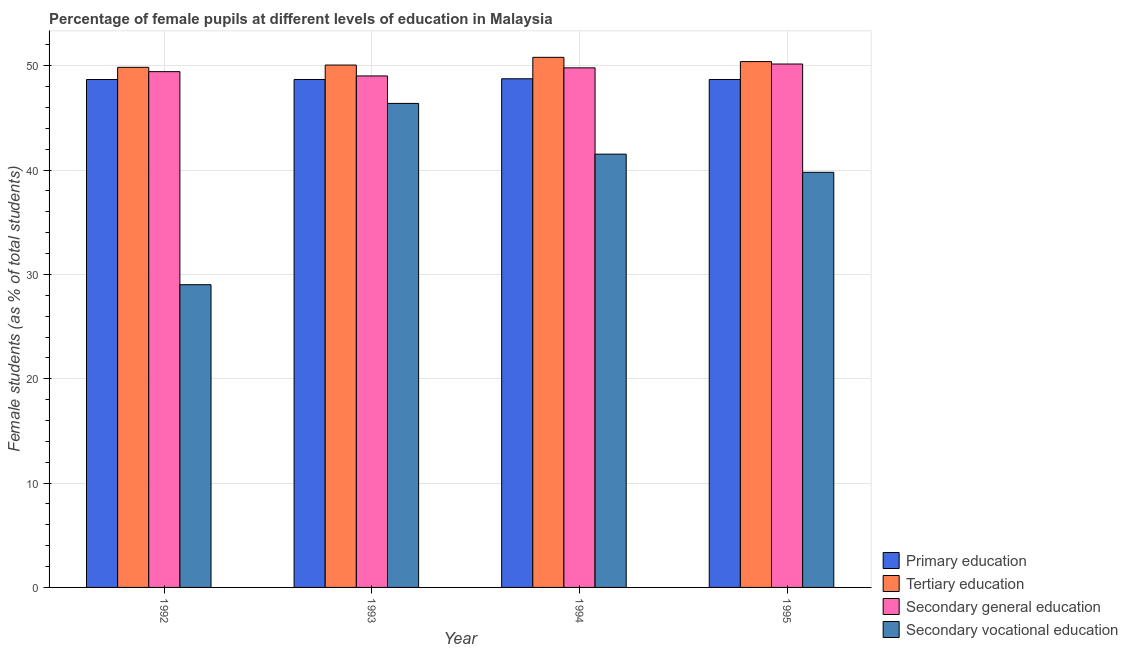How many bars are there on the 4th tick from the left?
Make the answer very short. 4. How many bars are there on the 1st tick from the right?
Make the answer very short. 4. What is the label of the 3rd group of bars from the left?
Provide a short and direct response. 1994. In how many cases, is the number of bars for a given year not equal to the number of legend labels?
Provide a short and direct response. 0. What is the percentage of female students in tertiary education in 1993?
Your answer should be very brief. 50.07. Across all years, what is the maximum percentage of female students in secondary vocational education?
Offer a very short reply. 46.39. Across all years, what is the minimum percentage of female students in secondary education?
Your answer should be very brief. 49.03. What is the total percentage of female students in tertiary education in the graph?
Offer a very short reply. 201.14. What is the difference between the percentage of female students in tertiary education in 1993 and that in 1995?
Provide a succinct answer. -0.33. What is the difference between the percentage of female students in secondary vocational education in 1992 and the percentage of female students in primary education in 1994?
Your answer should be very brief. -12.52. What is the average percentage of female students in primary education per year?
Give a very brief answer. 48.7. In how many years, is the percentage of female students in secondary vocational education greater than 48 %?
Your answer should be compact. 0. What is the ratio of the percentage of female students in secondary vocational education in 1994 to that in 1995?
Give a very brief answer. 1.04. Is the percentage of female students in secondary vocational education in 1993 less than that in 1994?
Your response must be concise. No. Is the difference between the percentage of female students in tertiary education in 1992 and 1994 greater than the difference between the percentage of female students in primary education in 1992 and 1994?
Provide a succinct answer. No. What is the difference between the highest and the second highest percentage of female students in secondary education?
Offer a terse response. 0.37. What is the difference between the highest and the lowest percentage of female students in secondary education?
Keep it short and to the point. 1.14. Is the sum of the percentage of female students in tertiary education in 1992 and 1995 greater than the maximum percentage of female students in primary education across all years?
Provide a short and direct response. Yes. Is it the case that in every year, the sum of the percentage of female students in primary education and percentage of female students in secondary education is greater than the sum of percentage of female students in secondary vocational education and percentage of female students in tertiary education?
Make the answer very short. No. What does the 3rd bar from the left in 1992 represents?
Your response must be concise. Secondary general education. What does the 3rd bar from the right in 1995 represents?
Your answer should be very brief. Tertiary education. How many bars are there?
Keep it short and to the point. 16. Are all the bars in the graph horizontal?
Your answer should be compact. No. What is the difference between two consecutive major ticks on the Y-axis?
Offer a very short reply. 10. Does the graph contain any zero values?
Make the answer very short. No. How are the legend labels stacked?
Make the answer very short. Vertical. What is the title of the graph?
Your answer should be very brief. Percentage of female pupils at different levels of education in Malaysia. Does "Social Protection" appear as one of the legend labels in the graph?
Give a very brief answer. No. What is the label or title of the X-axis?
Your answer should be very brief. Year. What is the label or title of the Y-axis?
Your response must be concise. Female students (as % of total students). What is the Female students (as % of total students) of Primary education in 1992?
Provide a succinct answer. 48.69. What is the Female students (as % of total students) in Tertiary education in 1992?
Provide a short and direct response. 49.85. What is the Female students (as % of total students) of Secondary general education in 1992?
Your answer should be very brief. 49.44. What is the Female students (as % of total students) of Secondary vocational education in 1992?
Keep it short and to the point. 29.02. What is the Female students (as % of total students) of Primary education in 1993?
Offer a terse response. 48.69. What is the Female students (as % of total students) in Tertiary education in 1993?
Your response must be concise. 50.07. What is the Female students (as % of total students) in Secondary general education in 1993?
Give a very brief answer. 49.03. What is the Female students (as % of total students) of Secondary vocational education in 1993?
Make the answer very short. 46.39. What is the Female students (as % of total students) of Primary education in 1994?
Your response must be concise. 48.76. What is the Female students (as % of total students) in Tertiary education in 1994?
Offer a very short reply. 50.81. What is the Female students (as % of total students) in Secondary general education in 1994?
Provide a short and direct response. 49.8. What is the Female students (as % of total students) in Secondary vocational education in 1994?
Keep it short and to the point. 41.53. What is the Female students (as % of total students) in Primary education in 1995?
Your response must be concise. 48.69. What is the Female students (as % of total students) in Tertiary education in 1995?
Offer a terse response. 50.4. What is the Female students (as % of total students) of Secondary general education in 1995?
Give a very brief answer. 50.17. What is the Female students (as % of total students) of Secondary vocational education in 1995?
Keep it short and to the point. 39.79. Across all years, what is the maximum Female students (as % of total students) in Primary education?
Your answer should be compact. 48.76. Across all years, what is the maximum Female students (as % of total students) of Tertiary education?
Provide a succinct answer. 50.81. Across all years, what is the maximum Female students (as % of total students) in Secondary general education?
Provide a short and direct response. 50.17. Across all years, what is the maximum Female students (as % of total students) in Secondary vocational education?
Offer a very short reply. 46.39. Across all years, what is the minimum Female students (as % of total students) of Primary education?
Your answer should be very brief. 48.69. Across all years, what is the minimum Female students (as % of total students) in Tertiary education?
Ensure brevity in your answer.  49.85. Across all years, what is the minimum Female students (as % of total students) of Secondary general education?
Provide a succinct answer. 49.03. Across all years, what is the minimum Female students (as % of total students) of Secondary vocational education?
Your answer should be compact. 29.02. What is the total Female students (as % of total students) of Primary education in the graph?
Give a very brief answer. 194.82. What is the total Female students (as % of total students) of Tertiary education in the graph?
Keep it short and to the point. 201.14. What is the total Female students (as % of total students) of Secondary general education in the graph?
Offer a terse response. 198.44. What is the total Female students (as % of total students) of Secondary vocational education in the graph?
Make the answer very short. 156.73. What is the difference between the Female students (as % of total students) of Primary education in 1992 and that in 1993?
Ensure brevity in your answer.  -0. What is the difference between the Female students (as % of total students) of Tertiary education in 1992 and that in 1993?
Your answer should be compact. -0.22. What is the difference between the Female students (as % of total students) in Secondary general education in 1992 and that in 1993?
Your response must be concise. 0.41. What is the difference between the Female students (as % of total students) in Secondary vocational education in 1992 and that in 1993?
Your response must be concise. -17.38. What is the difference between the Female students (as % of total students) of Primary education in 1992 and that in 1994?
Your answer should be very brief. -0.07. What is the difference between the Female students (as % of total students) in Tertiary education in 1992 and that in 1994?
Give a very brief answer. -0.96. What is the difference between the Female students (as % of total students) of Secondary general education in 1992 and that in 1994?
Offer a very short reply. -0.36. What is the difference between the Female students (as % of total students) of Secondary vocational education in 1992 and that in 1994?
Your response must be concise. -12.52. What is the difference between the Female students (as % of total students) in Primary education in 1992 and that in 1995?
Offer a very short reply. -0. What is the difference between the Female students (as % of total students) of Tertiary education in 1992 and that in 1995?
Provide a short and direct response. -0.55. What is the difference between the Female students (as % of total students) in Secondary general education in 1992 and that in 1995?
Your response must be concise. -0.73. What is the difference between the Female students (as % of total students) in Secondary vocational education in 1992 and that in 1995?
Give a very brief answer. -10.77. What is the difference between the Female students (as % of total students) of Primary education in 1993 and that in 1994?
Give a very brief answer. -0.07. What is the difference between the Female students (as % of total students) of Tertiary education in 1993 and that in 1994?
Make the answer very short. -0.74. What is the difference between the Female students (as % of total students) of Secondary general education in 1993 and that in 1994?
Provide a succinct answer. -0.78. What is the difference between the Female students (as % of total students) in Secondary vocational education in 1993 and that in 1994?
Make the answer very short. 4.86. What is the difference between the Female students (as % of total students) in Primary education in 1993 and that in 1995?
Ensure brevity in your answer.  -0. What is the difference between the Female students (as % of total students) of Tertiary education in 1993 and that in 1995?
Ensure brevity in your answer.  -0.33. What is the difference between the Female students (as % of total students) in Secondary general education in 1993 and that in 1995?
Your answer should be very brief. -1.14. What is the difference between the Female students (as % of total students) of Secondary vocational education in 1993 and that in 1995?
Provide a succinct answer. 6.61. What is the difference between the Female students (as % of total students) in Primary education in 1994 and that in 1995?
Provide a short and direct response. 0.07. What is the difference between the Female students (as % of total students) in Tertiary education in 1994 and that in 1995?
Give a very brief answer. 0.41. What is the difference between the Female students (as % of total students) of Secondary general education in 1994 and that in 1995?
Your answer should be very brief. -0.37. What is the difference between the Female students (as % of total students) of Secondary vocational education in 1994 and that in 1995?
Your answer should be very brief. 1.74. What is the difference between the Female students (as % of total students) in Primary education in 1992 and the Female students (as % of total students) in Tertiary education in 1993?
Make the answer very short. -1.38. What is the difference between the Female students (as % of total students) of Primary education in 1992 and the Female students (as % of total students) of Secondary general education in 1993?
Provide a short and direct response. -0.34. What is the difference between the Female students (as % of total students) of Primary education in 1992 and the Female students (as % of total students) of Secondary vocational education in 1993?
Provide a succinct answer. 2.29. What is the difference between the Female students (as % of total students) in Tertiary education in 1992 and the Female students (as % of total students) in Secondary general education in 1993?
Offer a terse response. 0.83. What is the difference between the Female students (as % of total students) of Tertiary education in 1992 and the Female students (as % of total students) of Secondary vocational education in 1993?
Provide a short and direct response. 3.46. What is the difference between the Female students (as % of total students) in Secondary general education in 1992 and the Female students (as % of total students) in Secondary vocational education in 1993?
Ensure brevity in your answer.  3.04. What is the difference between the Female students (as % of total students) of Primary education in 1992 and the Female students (as % of total students) of Tertiary education in 1994?
Give a very brief answer. -2.13. What is the difference between the Female students (as % of total students) in Primary education in 1992 and the Female students (as % of total students) in Secondary general education in 1994?
Offer a very short reply. -1.12. What is the difference between the Female students (as % of total students) of Primary education in 1992 and the Female students (as % of total students) of Secondary vocational education in 1994?
Give a very brief answer. 7.16. What is the difference between the Female students (as % of total students) of Tertiary education in 1992 and the Female students (as % of total students) of Secondary general education in 1994?
Offer a terse response. 0.05. What is the difference between the Female students (as % of total students) of Tertiary education in 1992 and the Female students (as % of total students) of Secondary vocational education in 1994?
Offer a terse response. 8.32. What is the difference between the Female students (as % of total students) of Secondary general education in 1992 and the Female students (as % of total students) of Secondary vocational education in 1994?
Offer a terse response. 7.91. What is the difference between the Female students (as % of total students) of Primary education in 1992 and the Female students (as % of total students) of Tertiary education in 1995?
Offer a terse response. -1.72. What is the difference between the Female students (as % of total students) in Primary education in 1992 and the Female students (as % of total students) in Secondary general education in 1995?
Make the answer very short. -1.48. What is the difference between the Female students (as % of total students) in Primary education in 1992 and the Female students (as % of total students) in Secondary vocational education in 1995?
Make the answer very short. 8.9. What is the difference between the Female students (as % of total students) in Tertiary education in 1992 and the Female students (as % of total students) in Secondary general education in 1995?
Your answer should be compact. -0.32. What is the difference between the Female students (as % of total students) in Tertiary education in 1992 and the Female students (as % of total students) in Secondary vocational education in 1995?
Ensure brevity in your answer.  10.06. What is the difference between the Female students (as % of total students) in Secondary general education in 1992 and the Female students (as % of total students) in Secondary vocational education in 1995?
Ensure brevity in your answer.  9.65. What is the difference between the Female students (as % of total students) of Primary education in 1993 and the Female students (as % of total students) of Tertiary education in 1994?
Keep it short and to the point. -2.12. What is the difference between the Female students (as % of total students) of Primary education in 1993 and the Female students (as % of total students) of Secondary general education in 1994?
Ensure brevity in your answer.  -1.11. What is the difference between the Female students (as % of total students) of Primary education in 1993 and the Female students (as % of total students) of Secondary vocational education in 1994?
Your answer should be compact. 7.16. What is the difference between the Female students (as % of total students) in Tertiary education in 1993 and the Female students (as % of total students) in Secondary general education in 1994?
Make the answer very short. 0.27. What is the difference between the Female students (as % of total students) of Tertiary education in 1993 and the Female students (as % of total students) of Secondary vocational education in 1994?
Provide a short and direct response. 8.54. What is the difference between the Female students (as % of total students) in Secondary general education in 1993 and the Female students (as % of total students) in Secondary vocational education in 1994?
Offer a terse response. 7.5. What is the difference between the Female students (as % of total students) in Primary education in 1993 and the Female students (as % of total students) in Tertiary education in 1995?
Give a very brief answer. -1.71. What is the difference between the Female students (as % of total students) in Primary education in 1993 and the Female students (as % of total students) in Secondary general education in 1995?
Offer a terse response. -1.48. What is the difference between the Female students (as % of total students) of Primary education in 1993 and the Female students (as % of total students) of Secondary vocational education in 1995?
Your answer should be very brief. 8.9. What is the difference between the Female students (as % of total students) in Tertiary education in 1993 and the Female students (as % of total students) in Secondary general education in 1995?
Your answer should be compact. -0.1. What is the difference between the Female students (as % of total students) of Tertiary education in 1993 and the Female students (as % of total students) of Secondary vocational education in 1995?
Provide a succinct answer. 10.28. What is the difference between the Female students (as % of total students) of Secondary general education in 1993 and the Female students (as % of total students) of Secondary vocational education in 1995?
Your response must be concise. 9.24. What is the difference between the Female students (as % of total students) in Primary education in 1994 and the Female students (as % of total students) in Tertiary education in 1995?
Provide a short and direct response. -1.65. What is the difference between the Female students (as % of total students) in Primary education in 1994 and the Female students (as % of total students) in Secondary general education in 1995?
Make the answer very short. -1.41. What is the difference between the Female students (as % of total students) in Primary education in 1994 and the Female students (as % of total students) in Secondary vocational education in 1995?
Make the answer very short. 8.97. What is the difference between the Female students (as % of total students) in Tertiary education in 1994 and the Female students (as % of total students) in Secondary general education in 1995?
Ensure brevity in your answer.  0.64. What is the difference between the Female students (as % of total students) of Tertiary education in 1994 and the Female students (as % of total students) of Secondary vocational education in 1995?
Provide a succinct answer. 11.02. What is the difference between the Female students (as % of total students) of Secondary general education in 1994 and the Female students (as % of total students) of Secondary vocational education in 1995?
Your response must be concise. 10.01. What is the average Female students (as % of total students) of Primary education per year?
Offer a very short reply. 48.7. What is the average Female students (as % of total students) in Tertiary education per year?
Provide a succinct answer. 50.28. What is the average Female students (as % of total students) in Secondary general education per year?
Offer a terse response. 49.61. What is the average Female students (as % of total students) of Secondary vocational education per year?
Give a very brief answer. 39.18. In the year 1992, what is the difference between the Female students (as % of total students) in Primary education and Female students (as % of total students) in Tertiary education?
Offer a terse response. -1.17. In the year 1992, what is the difference between the Female students (as % of total students) in Primary education and Female students (as % of total students) in Secondary general education?
Provide a succinct answer. -0.75. In the year 1992, what is the difference between the Female students (as % of total students) in Primary education and Female students (as % of total students) in Secondary vocational education?
Keep it short and to the point. 19.67. In the year 1992, what is the difference between the Female students (as % of total students) in Tertiary education and Female students (as % of total students) in Secondary general education?
Your answer should be compact. 0.41. In the year 1992, what is the difference between the Female students (as % of total students) of Tertiary education and Female students (as % of total students) of Secondary vocational education?
Your answer should be very brief. 20.84. In the year 1992, what is the difference between the Female students (as % of total students) of Secondary general education and Female students (as % of total students) of Secondary vocational education?
Offer a very short reply. 20.42. In the year 1993, what is the difference between the Female students (as % of total students) in Primary education and Female students (as % of total students) in Tertiary education?
Your answer should be very brief. -1.38. In the year 1993, what is the difference between the Female students (as % of total students) of Primary education and Female students (as % of total students) of Secondary general education?
Give a very brief answer. -0.34. In the year 1993, what is the difference between the Female students (as % of total students) of Primary education and Female students (as % of total students) of Secondary vocational education?
Give a very brief answer. 2.29. In the year 1993, what is the difference between the Female students (as % of total students) in Tertiary education and Female students (as % of total students) in Secondary general education?
Keep it short and to the point. 1.04. In the year 1993, what is the difference between the Female students (as % of total students) of Tertiary education and Female students (as % of total students) of Secondary vocational education?
Your response must be concise. 3.68. In the year 1993, what is the difference between the Female students (as % of total students) of Secondary general education and Female students (as % of total students) of Secondary vocational education?
Your answer should be compact. 2.63. In the year 1994, what is the difference between the Female students (as % of total students) of Primary education and Female students (as % of total students) of Tertiary education?
Offer a terse response. -2.05. In the year 1994, what is the difference between the Female students (as % of total students) in Primary education and Female students (as % of total students) in Secondary general education?
Your response must be concise. -1.05. In the year 1994, what is the difference between the Female students (as % of total students) in Primary education and Female students (as % of total students) in Secondary vocational education?
Provide a succinct answer. 7.23. In the year 1994, what is the difference between the Female students (as % of total students) of Tertiary education and Female students (as % of total students) of Secondary general education?
Your response must be concise. 1.01. In the year 1994, what is the difference between the Female students (as % of total students) of Tertiary education and Female students (as % of total students) of Secondary vocational education?
Your answer should be compact. 9.28. In the year 1994, what is the difference between the Female students (as % of total students) of Secondary general education and Female students (as % of total students) of Secondary vocational education?
Your response must be concise. 8.27. In the year 1995, what is the difference between the Female students (as % of total students) of Primary education and Female students (as % of total students) of Tertiary education?
Your answer should be very brief. -1.71. In the year 1995, what is the difference between the Female students (as % of total students) of Primary education and Female students (as % of total students) of Secondary general education?
Ensure brevity in your answer.  -1.48. In the year 1995, what is the difference between the Female students (as % of total students) of Primary education and Female students (as % of total students) of Secondary vocational education?
Ensure brevity in your answer.  8.9. In the year 1995, what is the difference between the Female students (as % of total students) of Tertiary education and Female students (as % of total students) of Secondary general education?
Keep it short and to the point. 0.23. In the year 1995, what is the difference between the Female students (as % of total students) of Tertiary education and Female students (as % of total students) of Secondary vocational education?
Provide a succinct answer. 10.61. In the year 1995, what is the difference between the Female students (as % of total students) of Secondary general education and Female students (as % of total students) of Secondary vocational education?
Keep it short and to the point. 10.38. What is the ratio of the Female students (as % of total students) in Primary education in 1992 to that in 1993?
Your answer should be compact. 1. What is the ratio of the Female students (as % of total students) of Secondary general education in 1992 to that in 1993?
Your response must be concise. 1.01. What is the ratio of the Female students (as % of total students) in Secondary vocational education in 1992 to that in 1993?
Give a very brief answer. 0.63. What is the ratio of the Female students (as % of total students) in Tertiary education in 1992 to that in 1994?
Provide a succinct answer. 0.98. What is the ratio of the Female students (as % of total students) in Secondary general education in 1992 to that in 1994?
Your response must be concise. 0.99. What is the ratio of the Female students (as % of total students) of Secondary vocational education in 1992 to that in 1994?
Provide a succinct answer. 0.7. What is the ratio of the Female students (as % of total students) of Tertiary education in 1992 to that in 1995?
Your response must be concise. 0.99. What is the ratio of the Female students (as % of total students) of Secondary general education in 1992 to that in 1995?
Make the answer very short. 0.99. What is the ratio of the Female students (as % of total students) in Secondary vocational education in 1992 to that in 1995?
Your response must be concise. 0.73. What is the ratio of the Female students (as % of total students) of Tertiary education in 1993 to that in 1994?
Provide a succinct answer. 0.99. What is the ratio of the Female students (as % of total students) in Secondary general education in 1993 to that in 1994?
Your answer should be compact. 0.98. What is the ratio of the Female students (as % of total students) of Secondary vocational education in 1993 to that in 1994?
Make the answer very short. 1.12. What is the ratio of the Female students (as % of total students) of Primary education in 1993 to that in 1995?
Your answer should be compact. 1. What is the ratio of the Female students (as % of total students) in Secondary general education in 1993 to that in 1995?
Offer a very short reply. 0.98. What is the ratio of the Female students (as % of total students) of Secondary vocational education in 1993 to that in 1995?
Keep it short and to the point. 1.17. What is the ratio of the Female students (as % of total students) of Tertiary education in 1994 to that in 1995?
Offer a terse response. 1.01. What is the ratio of the Female students (as % of total students) of Secondary general education in 1994 to that in 1995?
Ensure brevity in your answer.  0.99. What is the ratio of the Female students (as % of total students) in Secondary vocational education in 1994 to that in 1995?
Your answer should be very brief. 1.04. What is the difference between the highest and the second highest Female students (as % of total students) of Primary education?
Give a very brief answer. 0.07. What is the difference between the highest and the second highest Female students (as % of total students) of Tertiary education?
Your answer should be compact. 0.41. What is the difference between the highest and the second highest Female students (as % of total students) of Secondary general education?
Keep it short and to the point. 0.37. What is the difference between the highest and the second highest Female students (as % of total students) of Secondary vocational education?
Keep it short and to the point. 4.86. What is the difference between the highest and the lowest Female students (as % of total students) of Primary education?
Offer a terse response. 0.07. What is the difference between the highest and the lowest Female students (as % of total students) in Tertiary education?
Your answer should be compact. 0.96. What is the difference between the highest and the lowest Female students (as % of total students) of Secondary general education?
Make the answer very short. 1.14. What is the difference between the highest and the lowest Female students (as % of total students) in Secondary vocational education?
Your answer should be very brief. 17.38. 